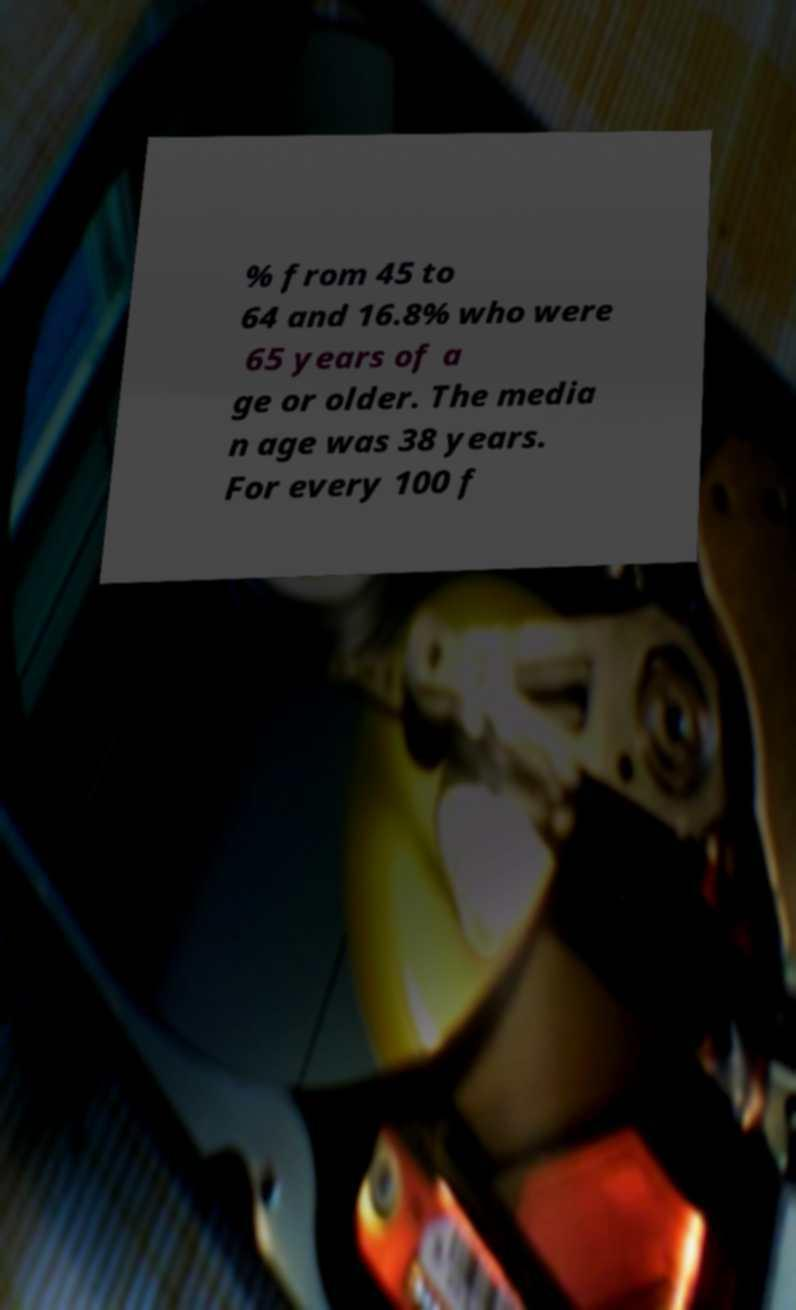Please read and relay the text visible in this image. What does it say? % from 45 to 64 and 16.8% who were 65 years of a ge or older. The media n age was 38 years. For every 100 f 